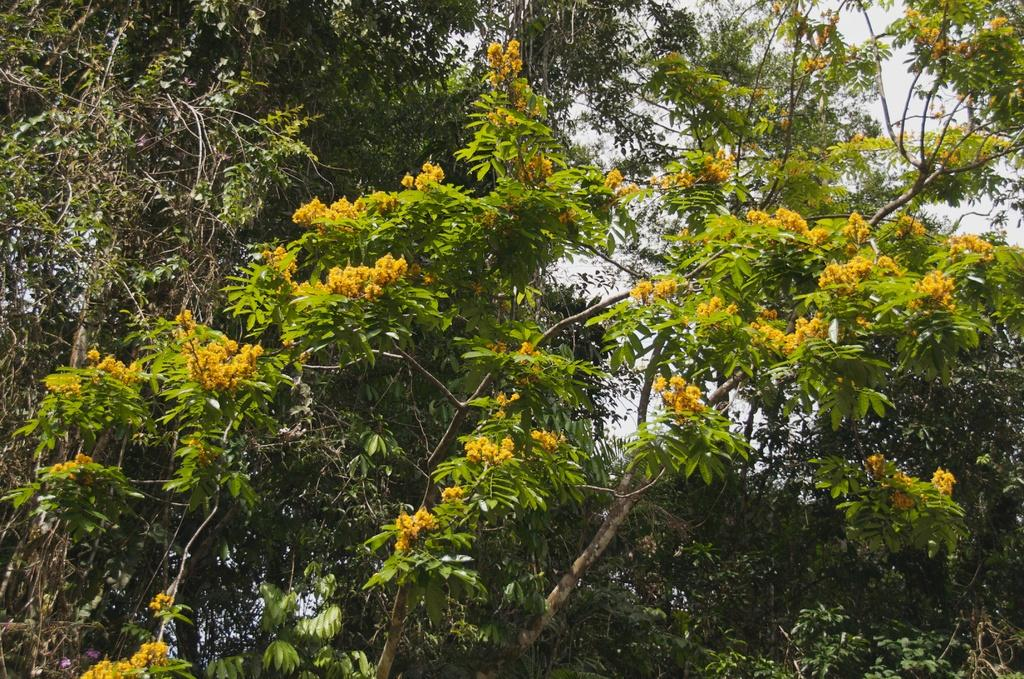What type of vegetation can be seen in the image? There are trees in the image. What other natural elements are present in the image? There are flowers in the image. What color are the flowers? The flowers are yellow in color. How many boys are playing with the yellow flowers in the image? There are no boys present in the image, and the flowers are not being played with. 